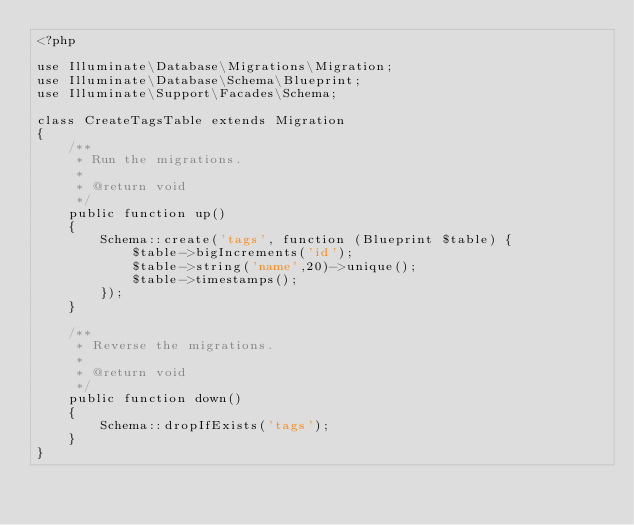<code> <loc_0><loc_0><loc_500><loc_500><_PHP_><?php

use Illuminate\Database\Migrations\Migration;
use Illuminate\Database\Schema\Blueprint;
use Illuminate\Support\Facades\Schema;

class CreateTagsTable extends Migration
{
    /**
     * Run the migrations.
     *
     * @return void
     */
    public function up()
    {
        Schema::create('tags', function (Blueprint $table) {
            $table->bigIncrements('id');
            $table->string('name',20)->unique();
            $table->timestamps();
        });
    }

    /**
     * Reverse the migrations.
     *
     * @return void
     */
    public function down()
    {
        Schema::dropIfExists('tags');
    }
}
</code> 